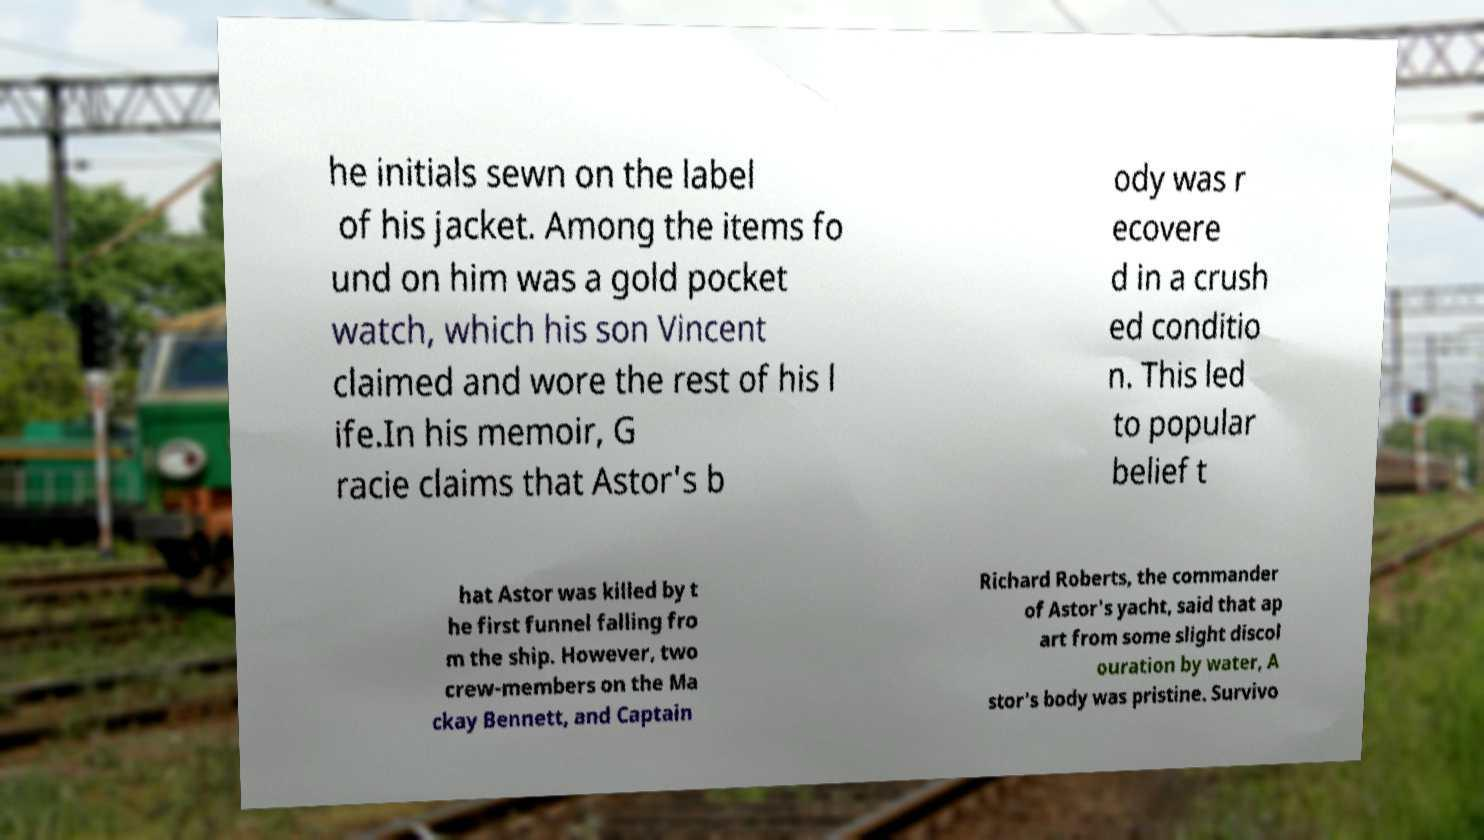Please identify and transcribe the text found in this image. he initials sewn on the label of his jacket. Among the items fo und on him was a gold pocket watch, which his son Vincent claimed and wore the rest of his l ife.In his memoir, G racie claims that Astor's b ody was r ecovere d in a crush ed conditio n. This led to popular belief t hat Astor was killed by t he first funnel falling fro m the ship. However, two crew-members on the Ma ckay Bennett, and Captain Richard Roberts, the commander of Astor's yacht, said that ap art from some slight discol ouration by water, A stor's body was pristine. Survivo 